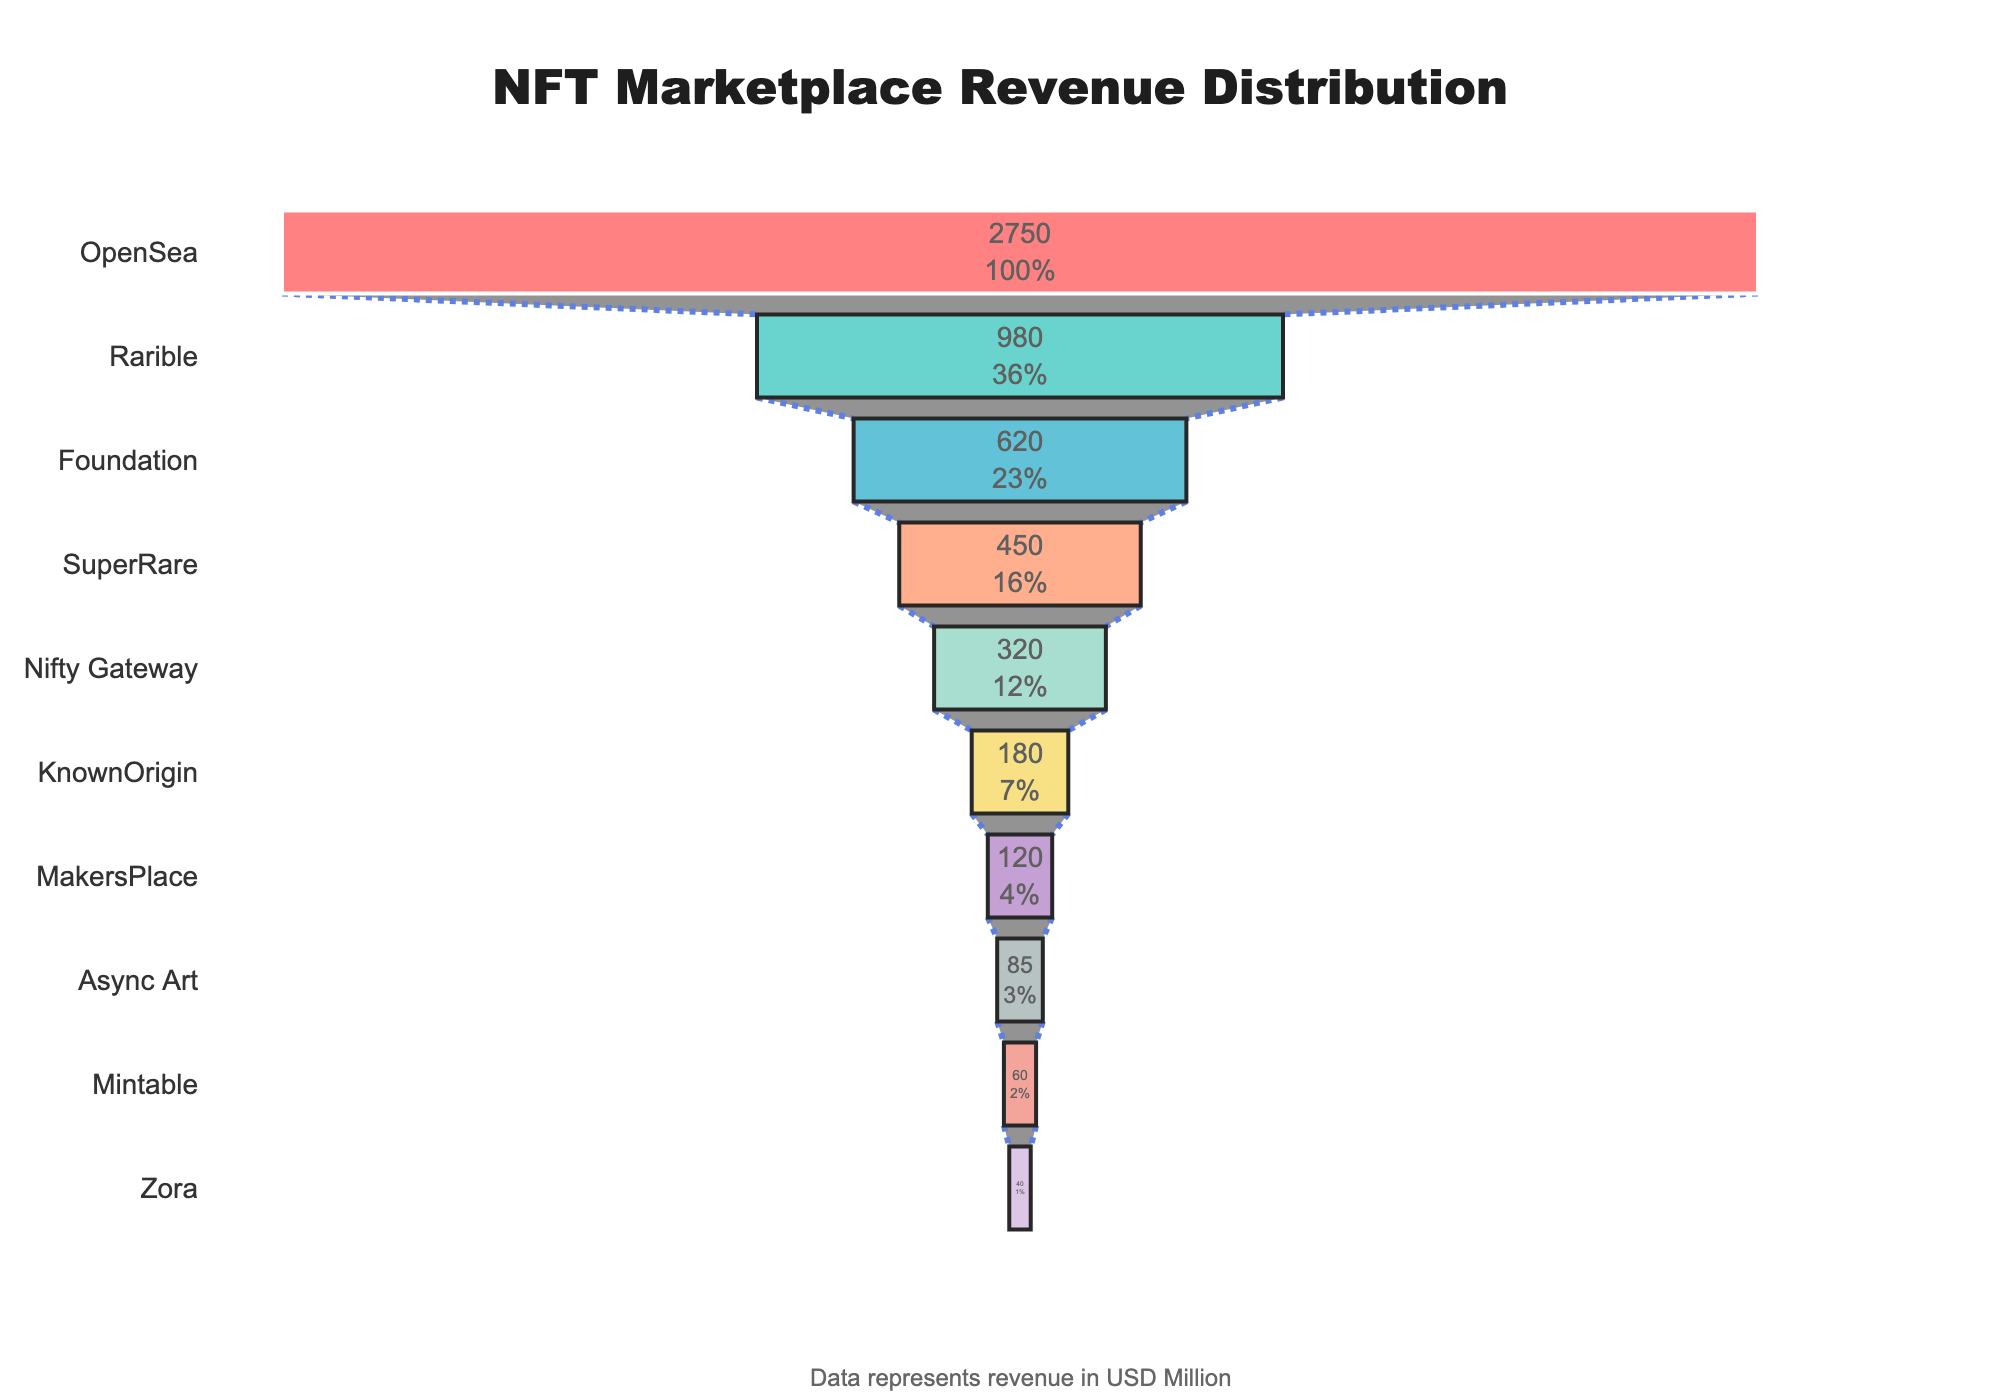What is the title of the chart? The title is located at the top center of the chart, mentioning the overall topic of the figure, which is about the distribution of the revenue among different NFT marketplaces.
Answer: NFT Marketplace Revenue Distribution How many NFT marketplaces are shown in the chart? The number of marketplaces can be determined by counting the segments in the funnel chart. Each segment represents one marketplace.
Answer: 10 Which NFT marketplace has the highest revenue? The marketplace with the highest revenue is shown at the widest part of the funnel, on the top.
Answer: OpenSea What percentage of the initial total revenue is contributed by OpenSea? The chart includes text data that specifies the percentage contribution of each marketplace relative to the initial total revenue.
Answer: 59.50% What is the cumulative revenue of the top three marketplaces? Sum the revenue values of the top three marketplaces: OpenSea, Rarible, and Foundation; 2750 + 980 + 620.
Answer: 4,350 Million What is the difference in revenue between Rarible and SuperRare? Subtract the revenue of SuperRare from the revenue of Rarible: 980 - 450.
Answer: 530 Million How does the revenue of MakersPlace compare to Nifty Gateway? Compare the revenue values directly: 120 (MakersPlace) vs. 320 (Nifty Gateway).
Answer: MakersPlace has less revenue What is the trend of revenue as we move from the top to the bottom of the funnel chart? Observe the funnel chart: the width of the funnel segments decreases from the top to the bottom, indicating a declining trend in revenue.
Answer: Declining trend Between KnownOrigin and Async Art, which marketplace has a higher revenue? Compare the revenue values directly: KnownOrigin (180) vs. Async Art (85).
Answer: KnownOrigin What is the combined revenue of the bottom five marketplaces? Sum the revenue values of the bottom five marketplaces: KnownOrigin, MakersPlace, Async Art, Mintable, and Zora; (180 + 120 + 85 + 60 + 40).
Answer: 485 Million 